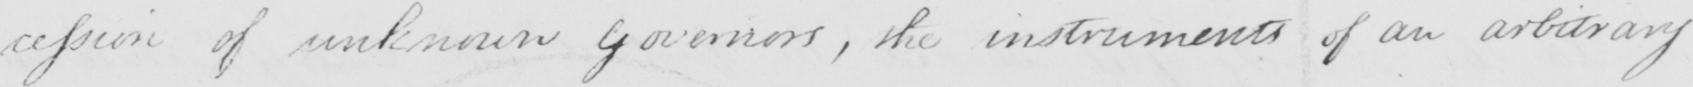Can you read and transcribe this handwriting? -cession of unknown Governors , the instruments of an arbitrary 